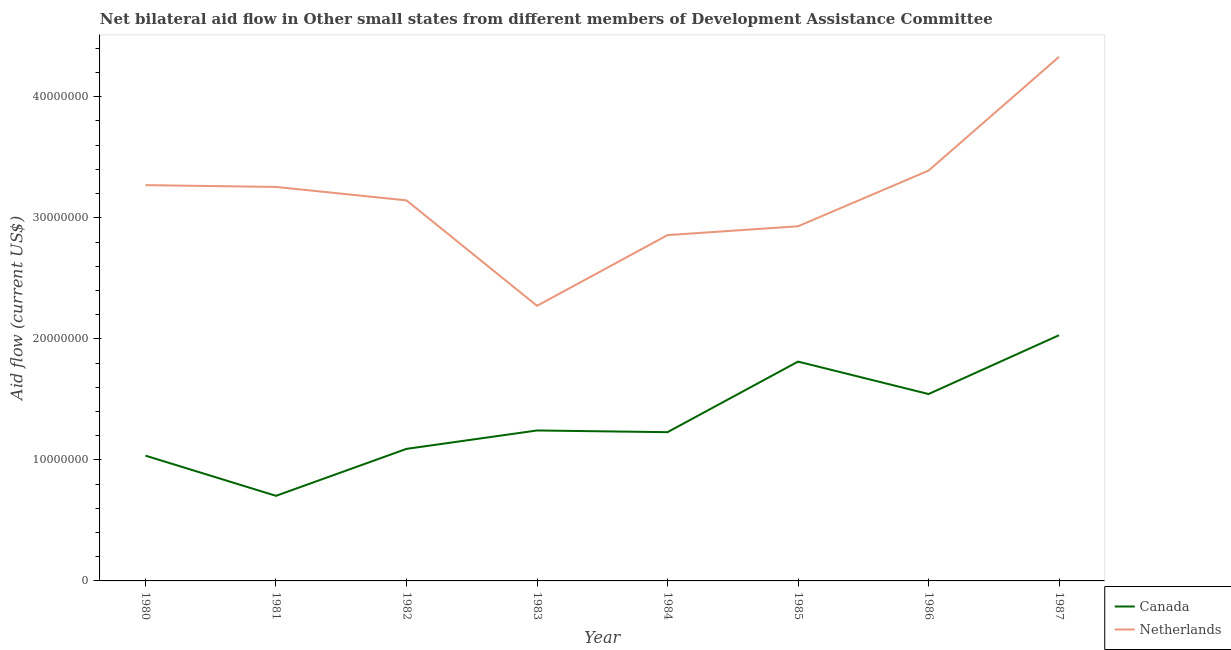Is the number of lines equal to the number of legend labels?
Provide a short and direct response. Yes. What is the amount of aid given by netherlands in 1982?
Your answer should be very brief. 3.14e+07. Across all years, what is the maximum amount of aid given by canada?
Ensure brevity in your answer.  2.03e+07. Across all years, what is the minimum amount of aid given by netherlands?
Your answer should be compact. 2.27e+07. What is the total amount of aid given by canada in the graph?
Keep it short and to the point. 1.07e+08. What is the difference between the amount of aid given by canada in 1983 and that in 1985?
Offer a very short reply. -5.69e+06. What is the difference between the amount of aid given by netherlands in 1981 and the amount of aid given by canada in 1980?
Give a very brief answer. 2.22e+07. What is the average amount of aid given by canada per year?
Provide a short and direct response. 1.34e+07. In the year 1986, what is the difference between the amount of aid given by canada and amount of aid given by netherlands?
Make the answer very short. -1.85e+07. What is the ratio of the amount of aid given by netherlands in 1985 to that in 1987?
Your response must be concise. 0.68. Is the amount of aid given by canada in 1980 less than that in 1982?
Provide a short and direct response. Yes. Is the difference between the amount of aid given by canada in 1982 and 1987 greater than the difference between the amount of aid given by netherlands in 1982 and 1987?
Provide a short and direct response. Yes. What is the difference between the highest and the second highest amount of aid given by netherlands?
Give a very brief answer. 9.40e+06. What is the difference between the highest and the lowest amount of aid given by canada?
Offer a very short reply. 1.33e+07. Is the sum of the amount of aid given by netherlands in 1981 and 1982 greater than the maximum amount of aid given by canada across all years?
Your answer should be compact. Yes. How many lines are there?
Make the answer very short. 2. What is the difference between two consecutive major ticks on the Y-axis?
Your answer should be very brief. 1.00e+07. Does the graph contain grids?
Ensure brevity in your answer.  No. How many legend labels are there?
Your answer should be compact. 2. How are the legend labels stacked?
Keep it short and to the point. Vertical. What is the title of the graph?
Your answer should be compact. Net bilateral aid flow in Other small states from different members of Development Assistance Committee. What is the label or title of the X-axis?
Make the answer very short. Year. What is the Aid flow (current US$) in Canada in 1980?
Your response must be concise. 1.04e+07. What is the Aid flow (current US$) of Netherlands in 1980?
Your response must be concise. 3.27e+07. What is the Aid flow (current US$) in Canada in 1981?
Your answer should be compact. 7.03e+06. What is the Aid flow (current US$) in Netherlands in 1981?
Offer a very short reply. 3.26e+07. What is the Aid flow (current US$) of Canada in 1982?
Your answer should be very brief. 1.09e+07. What is the Aid flow (current US$) of Netherlands in 1982?
Your answer should be compact. 3.14e+07. What is the Aid flow (current US$) in Canada in 1983?
Your answer should be very brief. 1.24e+07. What is the Aid flow (current US$) in Netherlands in 1983?
Your response must be concise. 2.27e+07. What is the Aid flow (current US$) of Canada in 1984?
Offer a very short reply. 1.23e+07. What is the Aid flow (current US$) of Netherlands in 1984?
Provide a short and direct response. 2.86e+07. What is the Aid flow (current US$) of Canada in 1985?
Your answer should be very brief. 1.81e+07. What is the Aid flow (current US$) of Netherlands in 1985?
Your response must be concise. 2.93e+07. What is the Aid flow (current US$) of Canada in 1986?
Offer a very short reply. 1.54e+07. What is the Aid flow (current US$) in Netherlands in 1986?
Keep it short and to the point. 3.39e+07. What is the Aid flow (current US$) in Canada in 1987?
Your response must be concise. 2.03e+07. What is the Aid flow (current US$) in Netherlands in 1987?
Ensure brevity in your answer.  4.33e+07. Across all years, what is the maximum Aid flow (current US$) in Canada?
Provide a short and direct response. 2.03e+07. Across all years, what is the maximum Aid flow (current US$) of Netherlands?
Your answer should be very brief. 4.33e+07. Across all years, what is the minimum Aid flow (current US$) of Canada?
Provide a succinct answer. 7.03e+06. Across all years, what is the minimum Aid flow (current US$) in Netherlands?
Your answer should be very brief. 2.27e+07. What is the total Aid flow (current US$) in Canada in the graph?
Offer a very short reply. 1.07e+08. What is the total Aid flow (current US$) of Netherlands in the graph?
Give a very brief answer. 2.54e+08. What is the difference between the Aid flow (current US$) of Canada in 1980 and that in 1981?
Your answer should be very brief. 3.32e+06. What is the difference between the Aid flow (current US$) of Netherlands in 1980 and that in 1981?
Your answer should be compact. 1.50e+05. What is the difference between the Aid flow (current US$) in Canada in 1980 and that in 1982?
Provide a succinct answer. -5.60e+05. What is the difference between the Aid flow (current US$) in Netherlands in 1980 and that in 1982?
Keep it short and to the point. 1.26e+06. What is the difference between the Aid flow (current US$) of Canada in 1980 and that in 1983?
Your response must be concise. -2.08e+06. What is the difference between the Aid flow (current US$) of Netherlands in 1980 and that in 1983?
Your answer should be very brief. 9.97e+06. What is the difference between the Aid flow (current US$) in Canada in 1980 and that in 1984?
Your answer should be compact. -1.94e+06. What is the difference between the Aid flow (current US$) in Netherlands in 1980 and that in 1984?
Your answer should be compact. 4.13e+06. What is the difference between the Aid flow (current US$) of Canada in 1980 and that in 1985?
Your response must be concise. -7.77e+06. What is the difference between the Aid flow (current US$) of Netherlands in 1980 and that in 1985?
Give a very brief answer. 3.40e+06. What is the difference between the Aid flow (current US$) in Canada in 1980 and that in 1986?
Ensure brevity in your answer.  -5.09e+06. What is the difference between the Aid flow (current US$) of Netherlands in 1980 and that in 1986?
Keep it short and to the point. -1.20e+06. What is the difference between the Aid flow (current US$) of Canada in 1980 and that in 1987?
Your answer should be very brief. -9.95e+06. What is the difference between the Aid flow (current US$) of Netherlands in 1980 and that in 1987?
Your answer should be very brief. -1.06e+07. What is the difference between the Aid flow (current US$) of Canada in 1981 and that in 1982?
Ensure brevity in your answer.  -3.88e+06. What is the difference between the Aid flow (current US$) in Netherlands in 1981 and that in 1982?
Your answer should be very brief. 1.11e+06. What is the difference between the Aid flow (current US$) in Canada in 1981 and that in 1983?
Offer a very short reply. -5.40e+06. What is the difference between the Aid flow (current US$) in Netherlands in 1981 and that in 1983?
Offer a very short reply. 9.82e+06. What is the difference between the Aid flow (current US$) of Canada in 1981 and that in 1984?
Give a very brief answer. -5.26e+06. What is the difference between the Aid flow (current US$) of Netherlands in 1981 and that in 1984?
Ensure brevity in your answer.  3.98e+06. What is the difference between the Aid flow (current US$) of Canada in 1981 and that in 1985?
Keep it short and to the point. -1.11e+07. What is the difference between the Aid flow (current US$) of Netherlands in 1981 and that in 1985?
Offer a terse response. 3.25e+06. What is the difference between the Aid flow (current US$) in Canada in 1981 and that in 1986?
Your answer should be compact. -8.41e+06. What is the difference between the Aid flow (current US$) in Netherlands in 1981 and that in 1986?
Provide a short and direct response. -1.35e+06. What is the difference between the Aid flow (current US$) in Canada in 1981 and that in 1987?
Give a very brief answer. -1.33e+07. What is the difference between the Aid flow (current US$) of Netherlands in 1981 and that in 1987?
Your answer should be compact. -1.08e+07. What is the difference between the Aid flow (current US$) in Canada in 1982 and that in 1983?
Offer a very short reply. -1.52e+06. What is the difference between the Aid flow (current US$) in Netherlands in 1982 and that in 1983?
Provide a short and direct response. 8.71e+06. What is the difference between the Aid flow (current US$) of Canada in 1982 and that in 1984?
Your answer should be compact. -1.38e+06. What is the difference between the Aid flow (current US$) in Netherlands in 1982 and that in 1984?
Your response must be concise. 2.87e+06. What is the difference between the Aid flow (current US$) of Canada in 1982 and that in 1985?
Your answer should be very brief. -7.21e+06. What is the difference between the Aid flow (current US$) of Netherlands in 1982 and that in 1985?
Your response must be concise. 2.14e+06. What is the difference between the Aid flow (current US$) of Canada in 1982 and that in 1986?
Your answer should be very brief. -4.53e+06. What is the difference between the Aid flow (current US$) of Netherlands in 1982 and that in 1986?
Give a very brief answer. -2.46e+06. What is the difference between the Aid flow (current US$) of Canada in 1982 and that in 1987?
Ensure brevity in your answer.  -9.39e+06. What is the difference between the Aid flow (current US$) in Netherlands in 1982 and that in 1987?
Make the answer very short. -1.19e+07. What is the difference between the Aid flow (current US$) in Canada in 1983 and that in 1984?
Give a very brief answer. 1.40e+05. What is the difference between the Aid flow (current US$) of Netherlands in 1983 and that in 1984?
Make the answer very short. -5.84e+06. What is the difference between the Aid flow (current US$) in Canada in 1983 and that in 1985?
Give a very brief answer. -5.69e+06. What is the difference between the Aid flow (current US$) of Netherlands in 1983 and that in 1985?
Provide a succinct answer. -6.57e+06. What is the difference between the Aid flow (current US$) in Canada in 1983 and that in 1986?
Your response must be concise. -3.01e+06. What is the difference between the Aid flow (current US$) of Netherlands in 1983 and that in 1986?
Your response must be concise. -1.12e+07. What is the difference between the Aid flow (current US$) in Canada in 1983 and that in 1987?
Make the answer very short. -7.87e+06. What is the difference between the Aid flow (current US$) of Netherlands in 1983 and that in 1987?
Your answer should be very brief. -2.06e+07. What is the difference between the Aid flow (current US$) of Canada in 1984 and that in 1985?
Your response must be concise. -5.83e+06. What is the difference between the Aid flow (current US$) in Netherlands in 1984 and that in 1985?
Offer a terse response. -7.30e+05. What is the difference between the Aid flow (current US$) of Canada in 1984 and that in 1986?
Ensure brevity in your answer.  -3.15e+06. What is the difference between the Aid flow (current US$) in Netherlands in 1984 and that in 1986?
Your response must be concise. -5.33e+06. What is the difference between the Aid flow (current US$) of Canada in 1984 and that in 1987?
Your answer should be very brief. -8.01e+06. What is the difference between the Aid flow (current US$) in Netherlands in 1984 and that in 1987?
Give a very brief answer. -1.47e+07. What is the difference between the Aid flow (current US$) in Canada in 1985 and that in 1986?
Your response must be concise. 2.68e+06. What is the difference between the Aid flow (current US$) in Netherlands in 1985 and that in 1986?
Offer a terse response. -4.60e+06. What is the difference between the Aid flow (current US$) of Canada in 1985 and that in 1987?
Your answer should be very brief. -2.18e+06. What is the difference between the Aid flow (current US$) in Netherlands in 1985 and that in 1987?
Ensure brevity in your answer.  -1.40e+07. What is the difference between the Aid flow (current US$) of Canada in 1986 and that in 1987?
Keep it short and to the point. -4.86e+06. What is the difference between the Aid flow (current US$) of Netherlands in 1986 and that in 1987?
Your answer should be very brief. -9.40e+06. What is the difference between the Aid flow (current US$) in Canada in 1980 and the Aid flow (current US$) in Netherlands in 1981?
Provide a short and direct response. -2.22e+07. What is the difference between the Aid flow (current US$) of Canada in 1980 and the Aid flow (current US$) of Netherlands in 1982?
Provide a succinct answer. -2.11e+07. What is the difference between the Aid flow (current US$) in Canada in 1980 and the Aid flow (current US$) in Netherlands in 1983?
Make the answer very short. -1.24e+07. What is the difference between the Aid flow (current US$) of Canada in 1980 and the Aid flow (current US$) of Netherlands in 1984?
Your answer should be very brief. -1.82e+07. What is the difference between the Aid flow (current US$) in Canada in 1980 and the Aid flow (current US$) in Netherlands in 1985?
Provide a succinct answer. -1.90e+07. What is the difference between the Aid flow (current US$) in Canada in 1980 and the Aid flow (current US$) in Netherlands in 1986?
Provide a succinct answer. -2.36e+07. What is the difference between the Aid flow (current US$) of Canada in 1980 and the Aid flow (current US$) of Netherlands in 1987?
Make the answer very short. -3.30e+07. What is the difference between the Aid flow (current US$) in Canada in 1981 and the Aid flow (current US$) in Netherlands in 1982?
Provide a short and direct response. -2.44e+07. What is the difference between the Aid flow (current US$) in Canada in 1981 and the Aid flow (current US$) in Netherlands in 1983?
Provide a succinct answer. -1.57e+07. What is the difference between the Aid flow (current US$) of Canada in 1981 and the Aid flow (current US$) of Netherlands in 1984?
Provide a succinct answer. -2.15e+07. What is the difference between the Aid flow (current US$) in Canada in 1981 and the Aid flow (current US$) in Netherlands in 1985?
Make the answer very short. -2.23e+07. What is the difference between the Aid flow (current US$) of Canada in 1981 and the Aid flow (current US$) of Netherlands in 1986?
Offer a very short reply. -2.69e+07. What is the difference between the Aid flow (current US$) in Canada in 1981 and the Aid flow (current US$) in Netherlands in 1987?
Ensure brevity in your answer.  -3.63e+07. What is the difference between the Aid flow (current US$) of Canada in 1982 and the Aid flow (current US$) of Netherlands in 1983?
Offer a terse response. -1.18e+07. What is the difference between the Aid flow (current US$) in Canada in 1982 and the Aid flow (current US$) in Netherlands in 1984?
Your answer should be very brief. -1.77e+07. What is the difference between the Aid flow (current US$) of Canada in 1982 and the Aid flow (current US$) of Netherlands in 1985?
Ensure brevity in your answer.  -1.84e+07. What is the difference between the Aid flow (current US$) of Canada in 1982 and the Aid flow (current US$) of Netherlands in 1986?
Make the answer very short. -2.30e+07. What is the difference between the Aid flow (current US$) in Canada in 1982 and the Aid flow (current US$) in Netherlands in 1987?
Offer a terse response. -3.24e+07. What is the difference between the Aid flow (current US$) in Canada in 1983 and the Aid flow (current US$) in Netherlands in 1984?
Keep it short and to the point. -1.61e+07. What is the difference between the Aid flow (current US$) of Canada in 1983 and the Aid flow (current US$) of Netherlands in 1985?
Your answer should be very brief. -1.69e+07. What is the difference between the Aid flow (current US$) in Canada in 1983 and the Aid flow (current US$) in Netherlands in 1986?
Your answer should be compact. -2.15e+07. What is the difference between the Aid flow (current US$) of Canada in 1983 and the Aid flow (current US$) of Netherlands in 1987?
Offer a terse response. -3.09e+07. What is the difference between the Aid flow (current US$) of Canada in 1984 and the Aid flow (current US$) of Netherlands in 1985?
Offer a terse response. -1.70e+07. What is the difference between the Aid flow (current US$) of Canada in 1984 and the Aid flow (current US$) of Netherlands in 1986?
Provide a succinct answer. -2.16e+07. What is the difference between the Aid flow (current US$) of Canada in 1984 and the Aid flow (current US$) of Netherlands in 1987?
Offer a very short reply. -3.10e+07. What is the difference between the Aid flow (current US$) in Canada in 1985 and the Aid flow (current US$) in Netherlands in 1986?
Make the answer very short. -1.58e+07. What is the difference between the Aid flow (current US$) in Canada in 1985 and the Aid flow (current US$) in Netherlands in 1987?
Keep it short and to the point. -2.52e+07. What is the difference between the Aid flow (current US$) in Canada in 1986 and the Aid flow (current US$) in Netherlands in 1987?
Give a very brief answer. -2.79e+07. What is the average Aid flow (current US$) in Canada per year?
Offer a terse response. 1.34e+07. What is the average Aid flow (current US$) in Netherlands per year?
Ensure brevity in your answer.  3.18e+07. In the year 1980, what is the difference between the Aid flow (current US$) in Canada and Aid flow (current US$) in Netherlands?
Ensure brevity in your answer.  -2.24e+07. In the year 1981, what is the difference between the Aid flow (current US$) in Canada and Aid flow (current US$) in Netherlands?
Offer a very short reply. -2.55e+07. In the year 1982, what is the difference between the Aid flow (current US$) of Canada and Aid flow (current US$) of Netherlands?
Give a very brief answer. -2.05e+07. In the year 1983, what is the difference between the Aid flow (current US$) of Canada and Aid flow (current US$) of Netherlands?
Ensure brevity in your answer.  -1.03e+07. In the year 1984, what is the difference between the Aid flow (current US$) of Canada and Aid flow (current US$) of Netherlands?
Provide a short and direct response. -1.63e+07. In the year 1985, what is the difference between the Aid flow (current US$) in Canada and Aid flow (current US$) in Netherlands?
Ensure brevity in your answer.  -1.12e+07. In the year 1986, what is the difference between the Aid flow (current US$) of Canada and Aid flow (current US$) of Netherlands?
Provide a short and direct response. -1.85e+07. In the year 1987, what is the difference between the Aid flow (current US$) of Canada and Aid flow (current US$) of Netherlands?
Your response must be concise. -2.30e+07. What is the ratio of the Aid flow (current US$) of Canada in 1980 to that in 1981?
Your answer should be compact. 1.47. What is the ratio of the Aid flow (current US$) in Netherlands in 1980 to that in 1981?
Make the answer very short. 1. What is the ratio of the Aid flow (current US$) of Canada in 1980 to that in 1982?
Offer a very short reply. 0.95. What is the ratio of the Aid flow (current US$) of Netherlands in 1980 to that in 1982?
Offer a very short reply. 1.04. What is the ratio of the Aid flow (current US$) in Canada in 1980 to that in 1983?
Your answer should be compact. 0.83. What is the ratio of the Aid flow (current US$) in Netherlands in 1980 to that in 1983?
Your answer should be compact. 1.44. What is the ratio of the Aid flow (current US$) of Canada in 1980 to that in 1984?
Give a very brief answer. 0.84. What is the ratio of the Aid flow (current US$) in Netherlands in 1980 to that in 1984?
Give a very brief answer. 1.14. What is the ratio of the Aid flow (current US$) in Canada in 1980 to that in 1985?
Make the answer very short. 0.57. What is the ratio of the Aid flow (current US$) of Netherlands in 1980 to that in 1985?
Make the answer very short. 1.12. What is the ratio of the Aid flow (current US$) in Canada in 1980 to that in 1986?
Provide a short and direct response. 0.67. What is the ratio of the Aid flow (current US$) in Netherlands in 1980 to that in 1986?
Your answer should be compact. 0.96. What is the ratio of the Aid flow (current US$) of Canada in 1980 to that in 1987?
Offer a very short reply. 0.51. What is the ratio of the Aid flow (current US$) of Netherlands in 1980 to that in 1987?
Your response must be concise. 0.76. What is the ratio of the Aid flow (current US$) of Canada in 1981 to that in 1982?
Provide a succinct answer. 0.64. What is the ratio of the Aid flow (current US$) of Netherlands in 1981 to that in 1982?
Ensure brevity in your answer.  1.04. What is the ratio of the Aid flow (current US$) of Canada in 1981 to that in 1983?
Keep it short and to the point. 0.57. What is the ratio of the Aid flow (current US$) of Netherlands in 1981 to that in 1983?
Offer a very short reply. 1.43. What is the ratio of the Aid flow (current US$) in Canada in 1981 to that in 1984?
Your answer should be compact. 0.57. What is the ratio of the Aid flow (current US$) in Netherlands in 1981 to that in 1984?
Your answer should be very brief. 1.14. What is the ratio of the Aid flow (current US$) in Canada in 1981 to that in 1985?
Provide a short and direct response. 0.39. What is the ratio of the Aid flow (current US$) of Netherlands in 1981 to that in 1985?
Provide a short and direct response. 1.11. What is the ratio of the Aid flow (current US$) in Canada in 1981 to that in 1986?
Provide a succinct answer. 0.46. What is the ratio of the Aid flow (current US$) of Netherlands in 1981 to that in 1986?
Ensure brevity in your answer.  0.96. What is the ratio of the Aid flow (current US$) in Canada in 1981 to that in 1987?
Your answer should be compact. 0.35. What is the ratio of the Aid flow (current US$) of Netherlands in 1981 to that in 1987?
Keep it short and to the point. 0.75. What is the ratio of the Aid flow (current US$) in Canada in 1982 to that in 1983?
Your answer should be very brief. 0.88. What is the ratio of the Aid flow (current US$) of Netherlands in 1982 to that in 1983?
Your answer should be very brief. 1.38. What is the ratio of the Aid flow (current US$) in Canada in 1982 to that in 1984?
Your response must be concise. 0.89. What is the ratio of the Aid flow (current US$) of Netherlands in 1982 to that in 1984?
Provide a short and direct response. 1.1. What is the ratio of the Aid flow (current US$) in Canada in 1982 to that in 1985?
Your response must be concise. 0.6. What is the ratio of the Aid flow (current US$) of Netherlands in 1982 to that in 1985?
Ensure brevity in your answer.  1.07. What is the ratio of the Aid flow (current US$) in Canada in 1982 to that in 1986?
Make the answer very short. 0.71. What is the ratio of the Aid flow (current US$) in Netherlands in 1982 to that in 1986?
Provide a short and direct response. 0.93. What is the ratio of the Aid flow (current US$) in Canada in 1982 to that in 1987?
Provide a short and direct response. 0.54. What is the ratio of the Aid flow (current US$) in Netherlands in 1982 to that in 1987?
Give a very brief answer. 0.73. What is the ratio of the Aid flow (current US$) of Canada in 1983 to that in 1984?
Keep it short and to the point. 1.01. What is the ratio of the Aid flow (current US$) of Netherlands in 1983 to that in 1984?
Offer a terse response. 0.8. What is the ratio of the Aid flow (current US$) in Canada in 1983 to that in 1985?
Ensure brevity in your answer.  0.69. What is the ratio of the Aid flow (current US$) in Netherlands in 1983 to that in 1985?
Your answer should be very brief. 0.78. What is the ratio of the Aid flow (current US$) in Canada in 1983 to that in 1986?
Your answer should be compact. 0.81. What is the ratio of the Aid flow (current US$) in Netherlands in 1983 to that in 1986?
Keep it short and to the point. 0.67. What is the ratio of the Aid flow (current US$) of Canada in 1983 to that in 1987?
Your response must be concise. 0.61. What is the ratio of the Aid flow (current US$) of Netherlands in 1983 to that in 1987?
Your answer should be very brief. 0.52. What is the ratio of the Aid flow (current US$) in Canada in 1984 to that in 1985?
Offer a very short reply. 0.68. What is the ratio of the Aid flow (current US$) of Netherlands in 1984 to that in 1985?
Offer a terse response. 0.98. What is the ratio of the Aid flow (current US$) in Canada in 1984 to that in 1986?
Offer a very short reply. 0.8. What is the ratio of the Aid flow (current US$) in Netherlands in 1984 to that in 1986?
Your answer should be compact. 0.84. What is the ratio of the Aid flow (current US$) in Canada in 1984 to that in 1987?
Give a very brief answer. 0.61. What is the ratio of the Aid flow (current US$) in Netherlands in 1984 to that in 1987?
Offer a very short reply. 0.66. What is the ratio of the Aid flow (current US$) in Canada in 1985 to that in 1986?
Keep it short and to the point. 1.17. What is the ratio of the Aid flow (current US$) in Netherlands in 1985 to that in 1986?
Your answer should be compact. 0.86. What is the ratio of the Aid flow (current US$) in Canada in 1985 to that in 1987?
Provide a short and direct response. 0.89. What is the ratio of the Aid flow (current US$) in Netherlands in 1985 to that in 1987?
Give a very brief answer. 0.68. What is the ratio of the Aid flow (current US$) of Canada in 1986 to that in 1987?
Ensure brevity in your answer.  0.76. What is the ratio of the Aid flow (current US$) of Netherlands in 1986 to that in 1987?
Provide a short and direct response. 0.78. What is the difference between the highest and the second highest Aid flow (current US$) in Canada?
Keep it short and to the point. 2.18e+06. What is the difference between the highest and the second highest Aid flow (current US$) in Netherlands?
Keep it short and to the point. 9.40e+06. What is the difference between the highest and the lowest Aid flow (current US$) in Canada?
Your answer should be compact. 1.33e+07. What is the difference between the highest and the lowest Aid flow (current US$) of Netherlands?
Keep it short and to the point. 2.06e+07. 